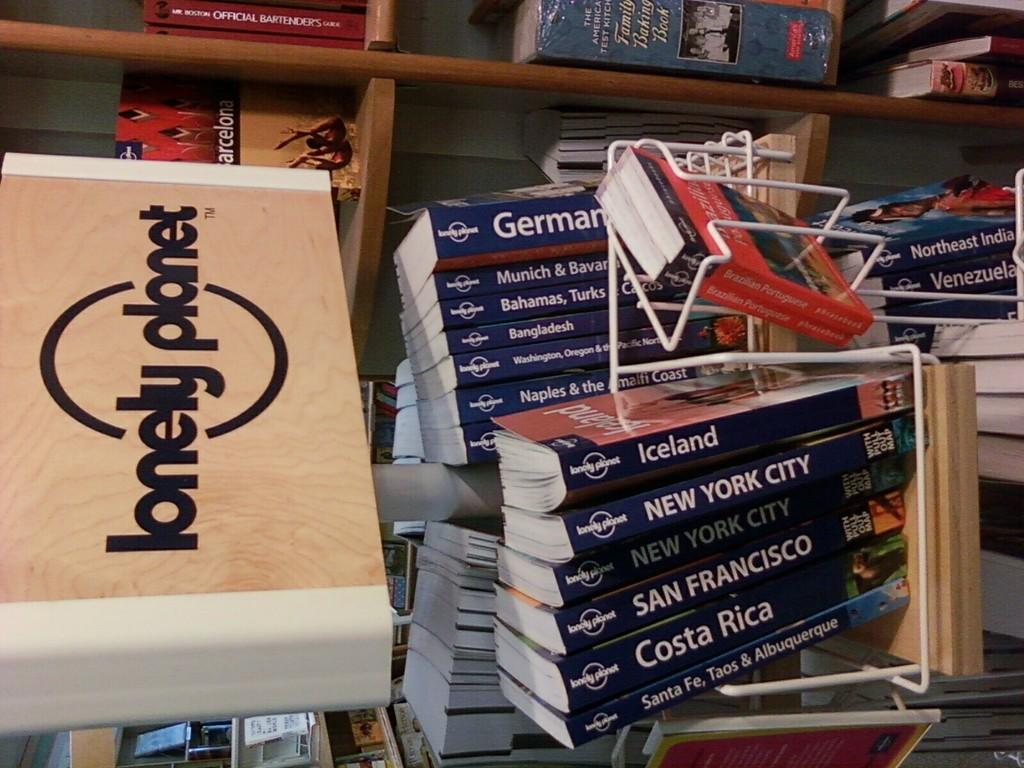<image>
Summarize the visual content of the image. box labeled lonely planet next to stack of books each with name of city or country 